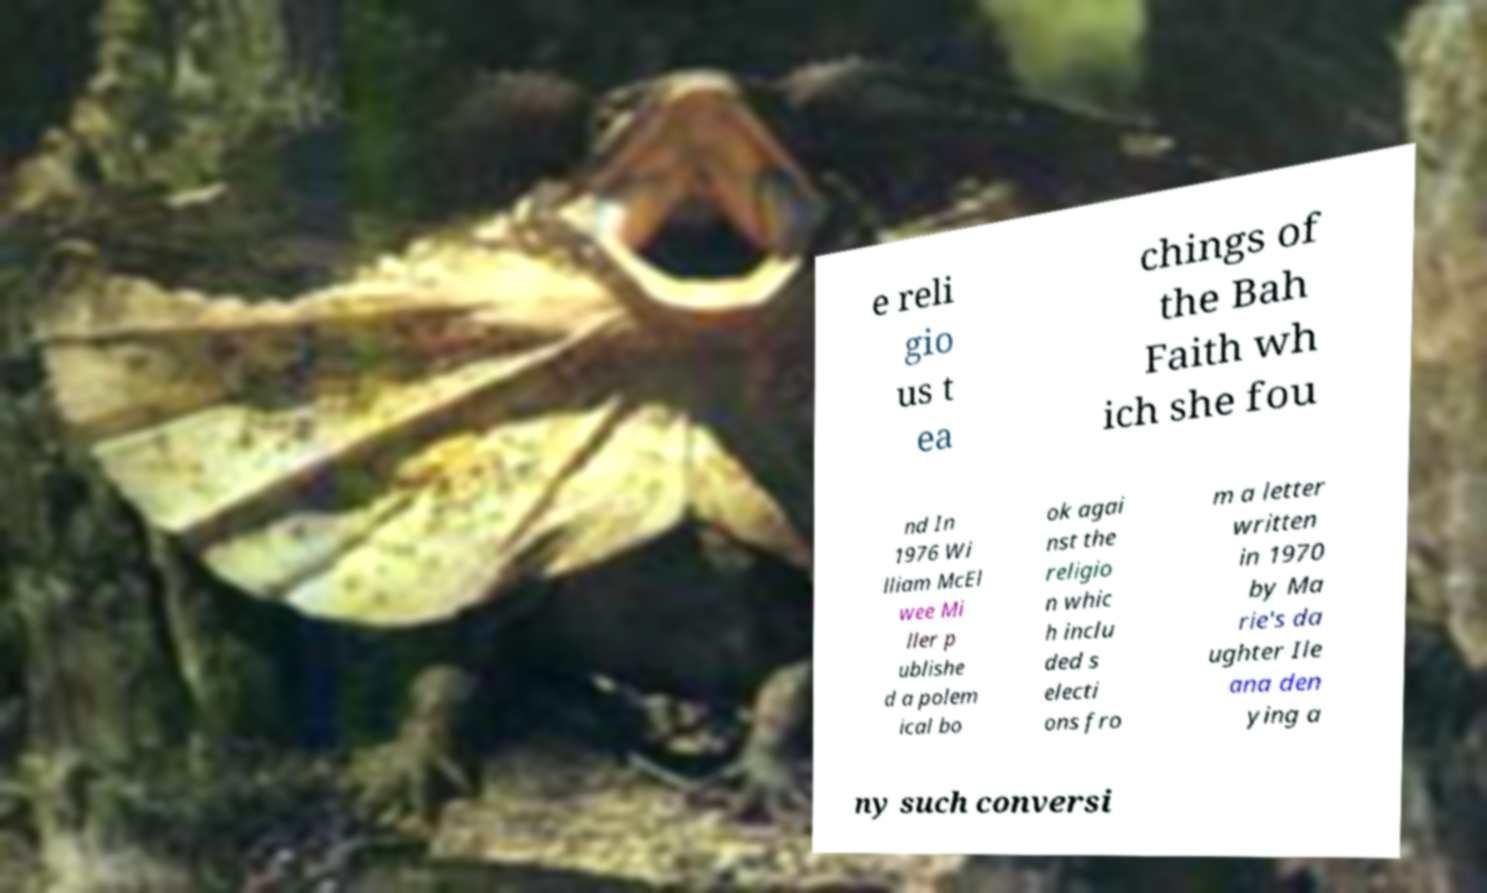Please read and relay the text visible in this image. What does it say? e reli gio us t ea chings of the Bah Faith wh ich she fou nd In 1976 Wi lliam McEl wee Mi ller p ublishe d a polem ical bo ok agai nst the religio n whic h inclu ded s electi ons fro m a letter written in 1970 by Ma rie's da ughter Ile ana den ying a ny such conversi 